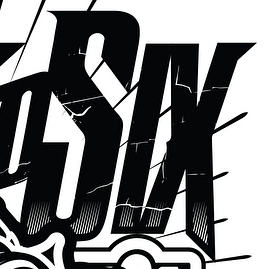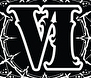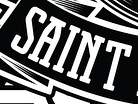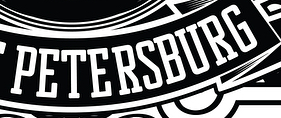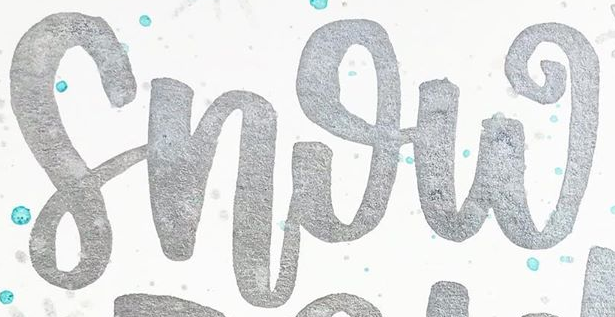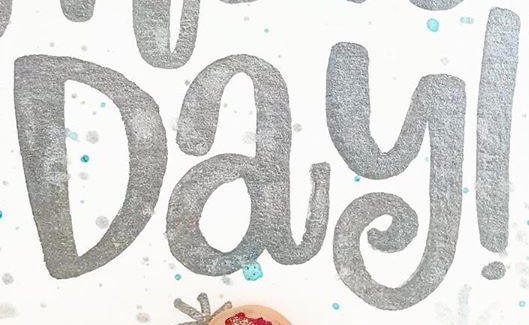What text is displayed in these images sequentially, separated by a semicolon? SIX; VI; SAINT; PETERSBURG; Snow; Day! 